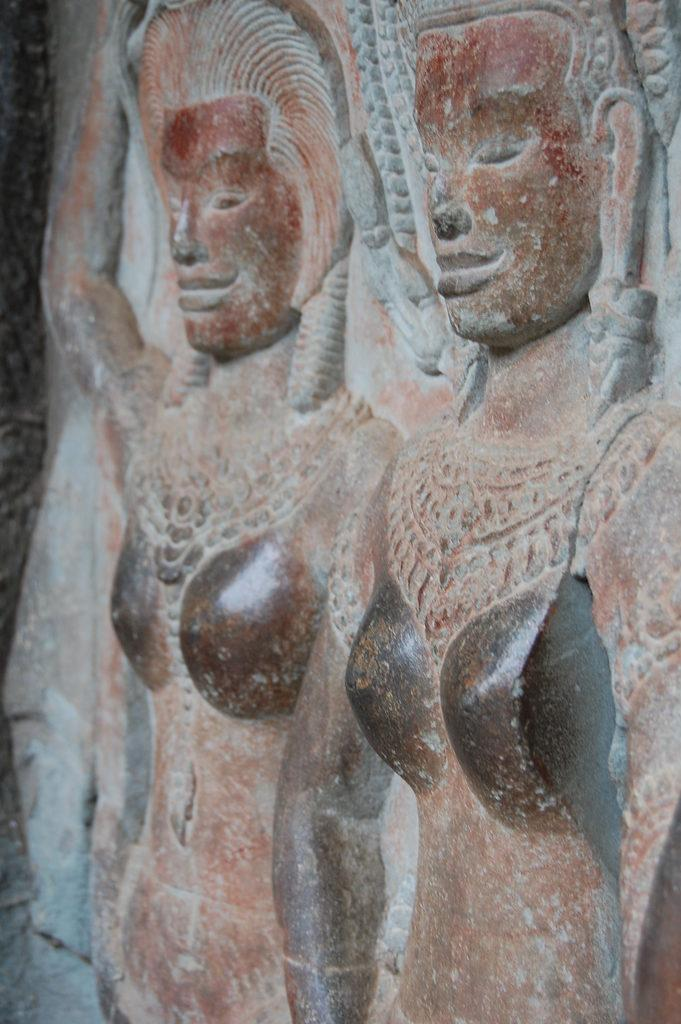Where was the image taken? The image was taken outdoors. What can be seen in the image? There is a sculpture of Egyptians in the image. What type of bait is being used by the Egyptians in the image? There is no bait present in the image, as it features a sculpture of Egyptians. How many fangs can be seen on the sculpture in the image? There are no fangs present on the sculpture in the image, as it depicts Egyptians. 